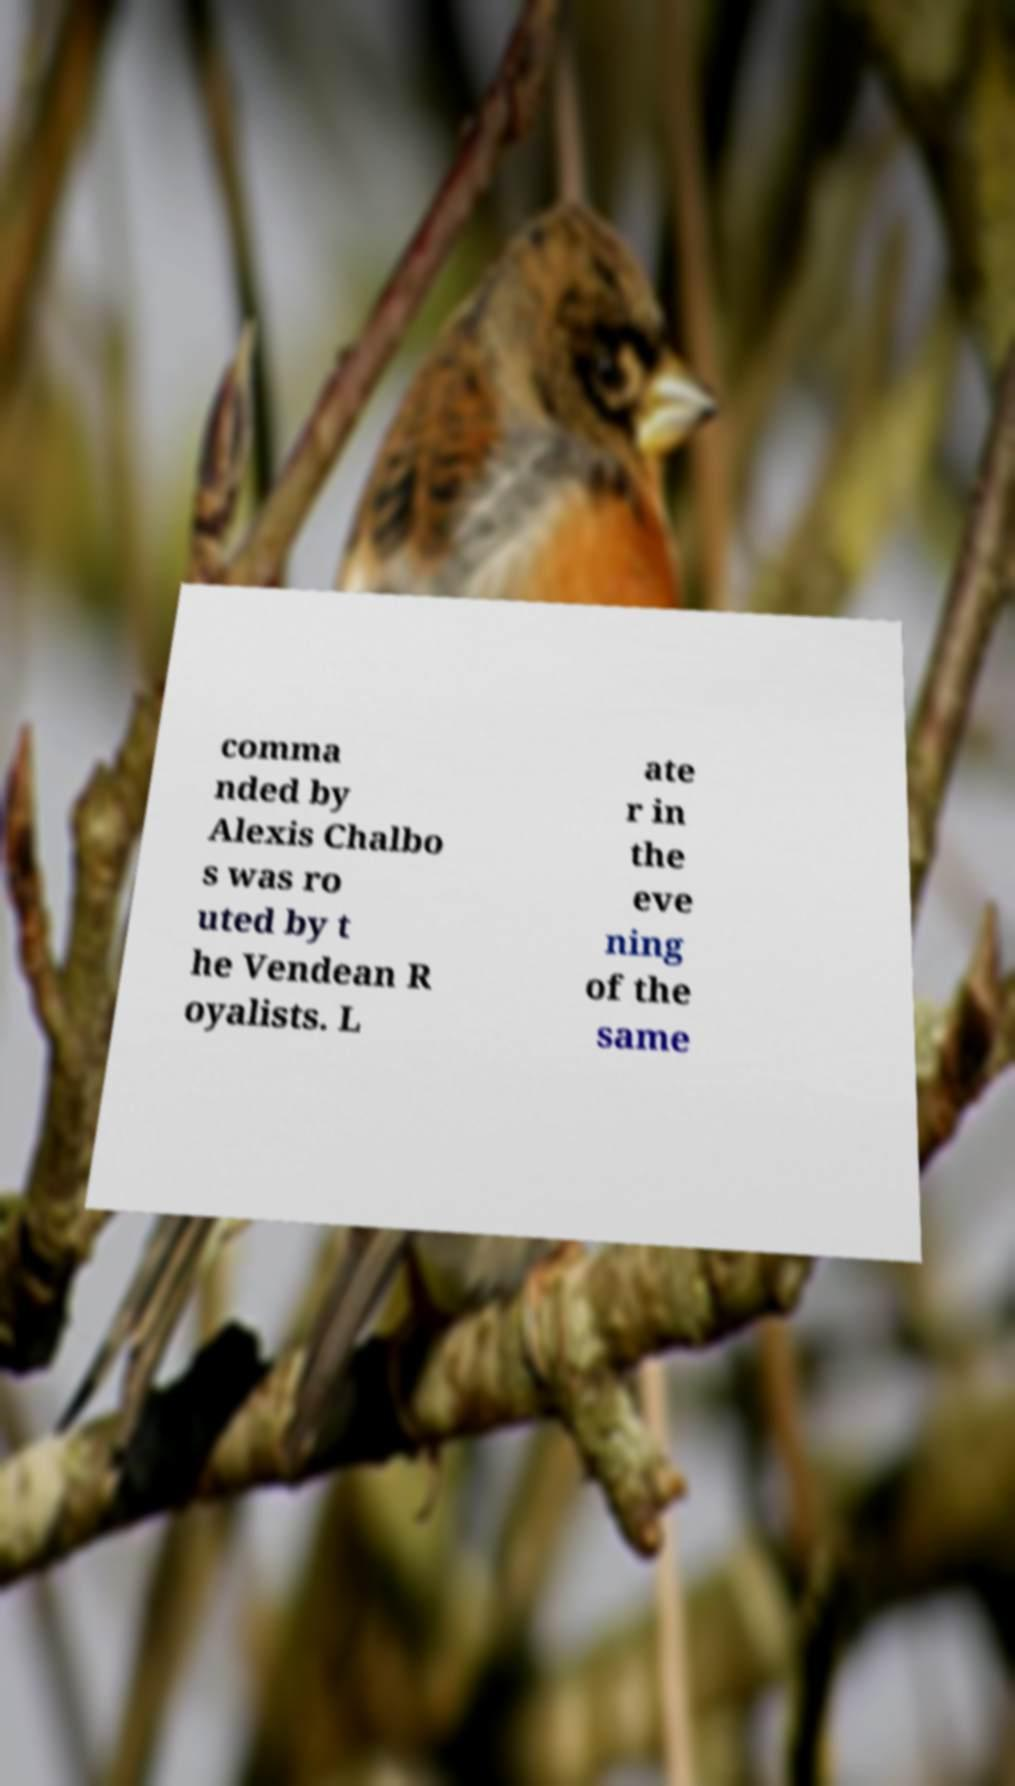Please read and relay the text visible in this image. What does it say? comma nded by Alexis Chalbo s was ro uted by t he Vendean R oyalists. L ate r in the eve ning of the same 